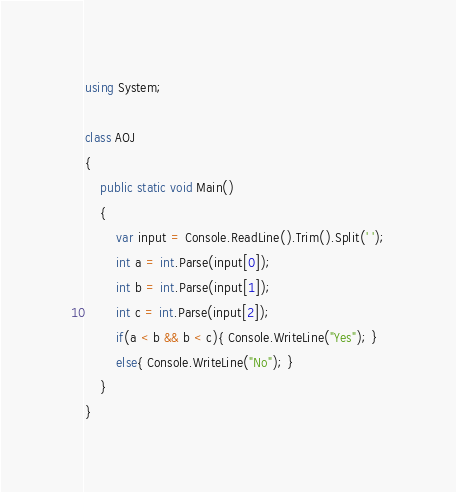<code> <loc_0><loc_0><loc_500><loc_500><_C#_>using System;

class AOJ
{
	public static void Main()
	{
		var input = Console.ReadLine().Trim().Split(' ');
		int a = int.Parse(input[0]);
		int b = int.Parse(input[1]);
		int c = int.Parse(input[2]);
		if(a < b && b < c){ Console.WriteLine("Yes"); }
		else{ Console.WriteLine("No"); }
	}
}</code> 